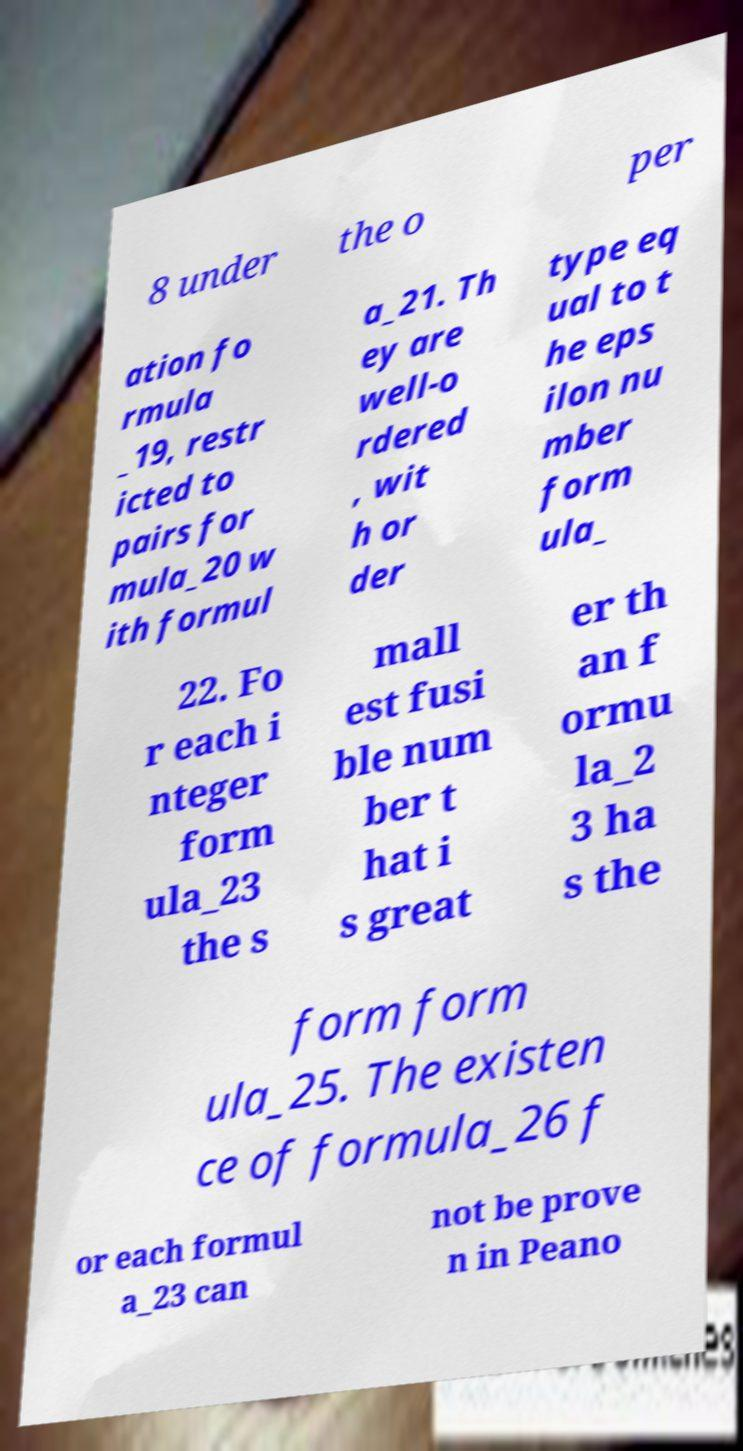Can you accurately transcribe the text from the provided image for me? 8 under the o per ation fo rmula _19, restr icted to pairs for mula_20 w ith formul a_21. Th ey are well-o rdered , wit h or der type eq ual to t he eps ilon nu mber form ula_ 22. Fo r each i nteger form ula_23 the s mall est fusi ble num ber t hat i s great er th an f ormu la_2 3 ha s the form form ula_25. The existen ce of formula_26 f or each formul a_23 can not be prove n in Peano 